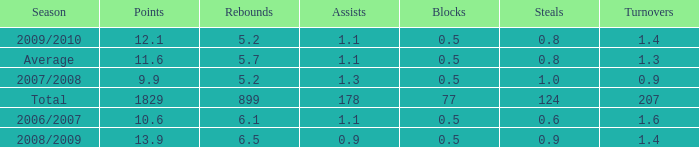How many blocks are there when the rebounds are fewer than 5.2? 0.0. 